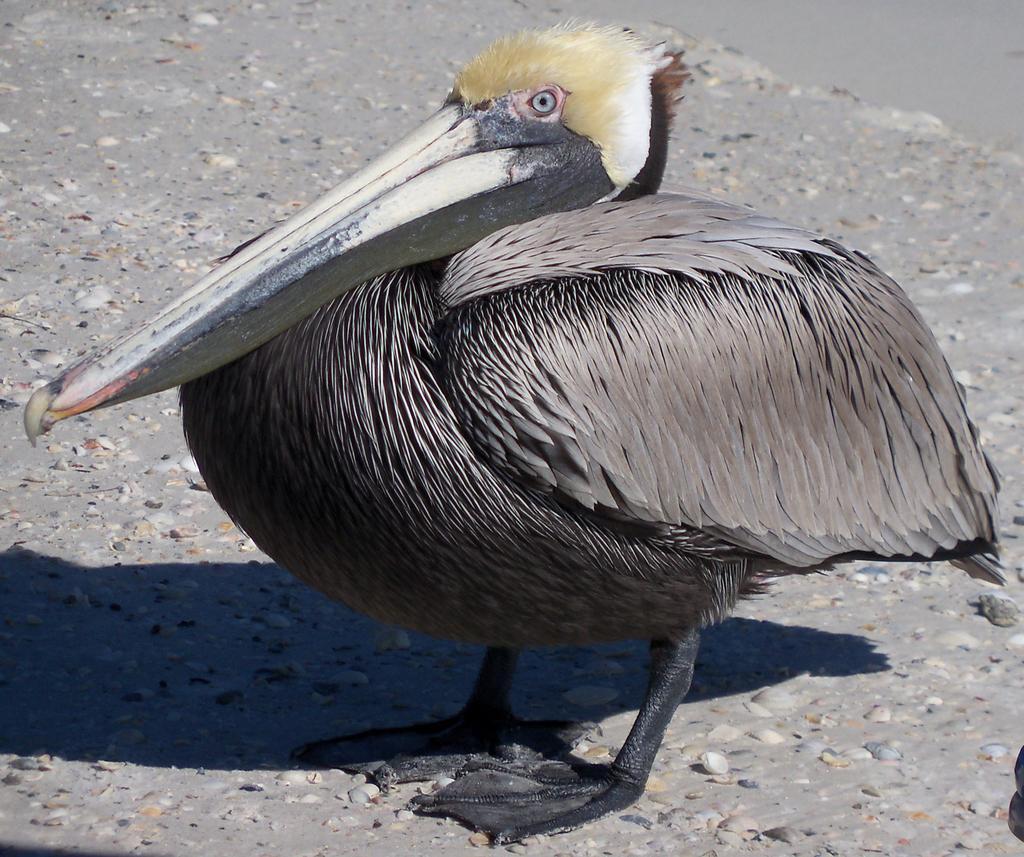Could you give a brief overview of what you see in this image? In this image we can see a bird on the ground, also we can see some stones. 